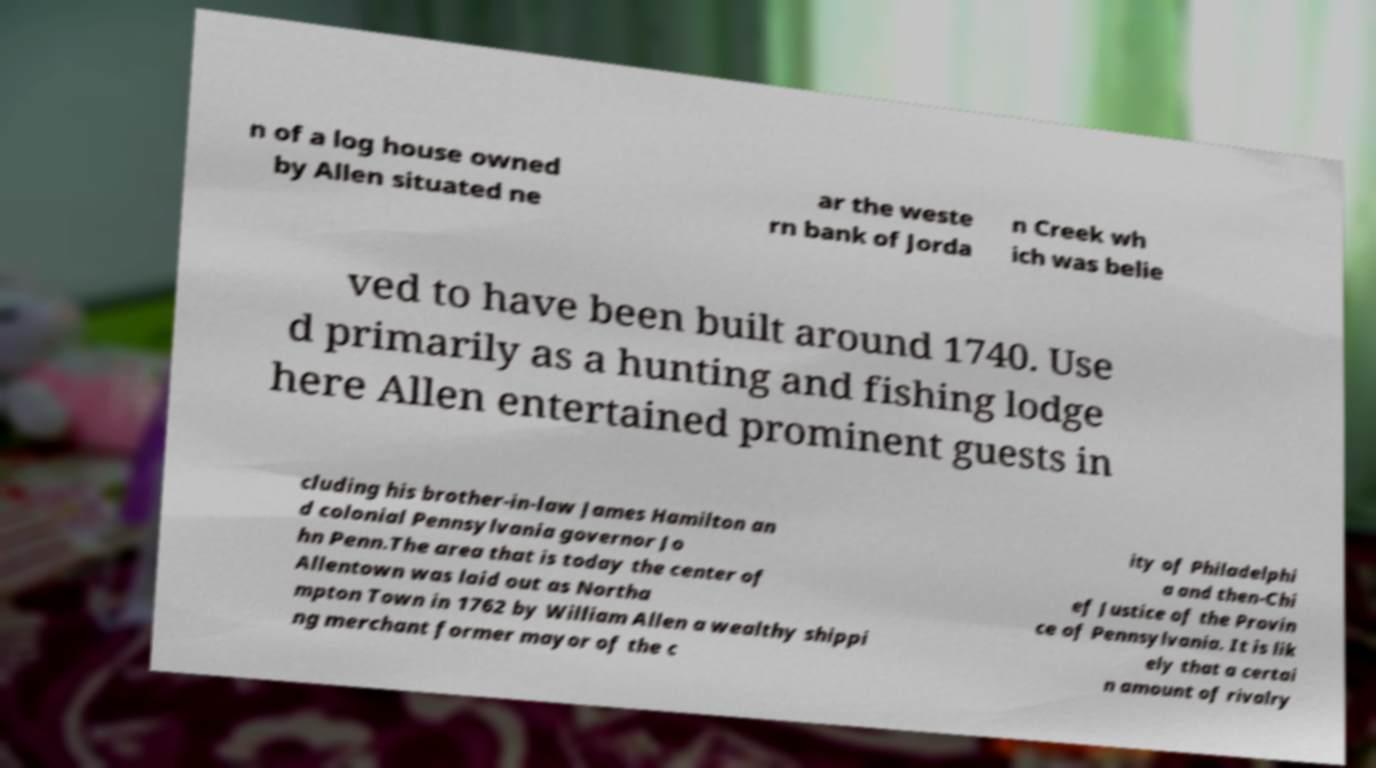Can you accurately transcribe the text from the provided image for me? n of a log house owned by Allen situated ne ar the weste rn bank of Jorda n Creek wh ich was belie ved to have been built around 1740. Use d primarily as a hunting and fishing lodge here Allen entertained prominent guests in cluding his brother-in-law James Hamilton an d colonial Pennsylvania governor Jo hn Penn.The area that is today the center of Allentown was laid out as Northa mpton Town in 1762 by William Allen a wealthy shippi ng merchant former mayor of the c ity of Philadelphi a and then-Chi ef Justice of the Provin ce of Pennsylvania. It is lik ely that a certai n amount of rivalry 